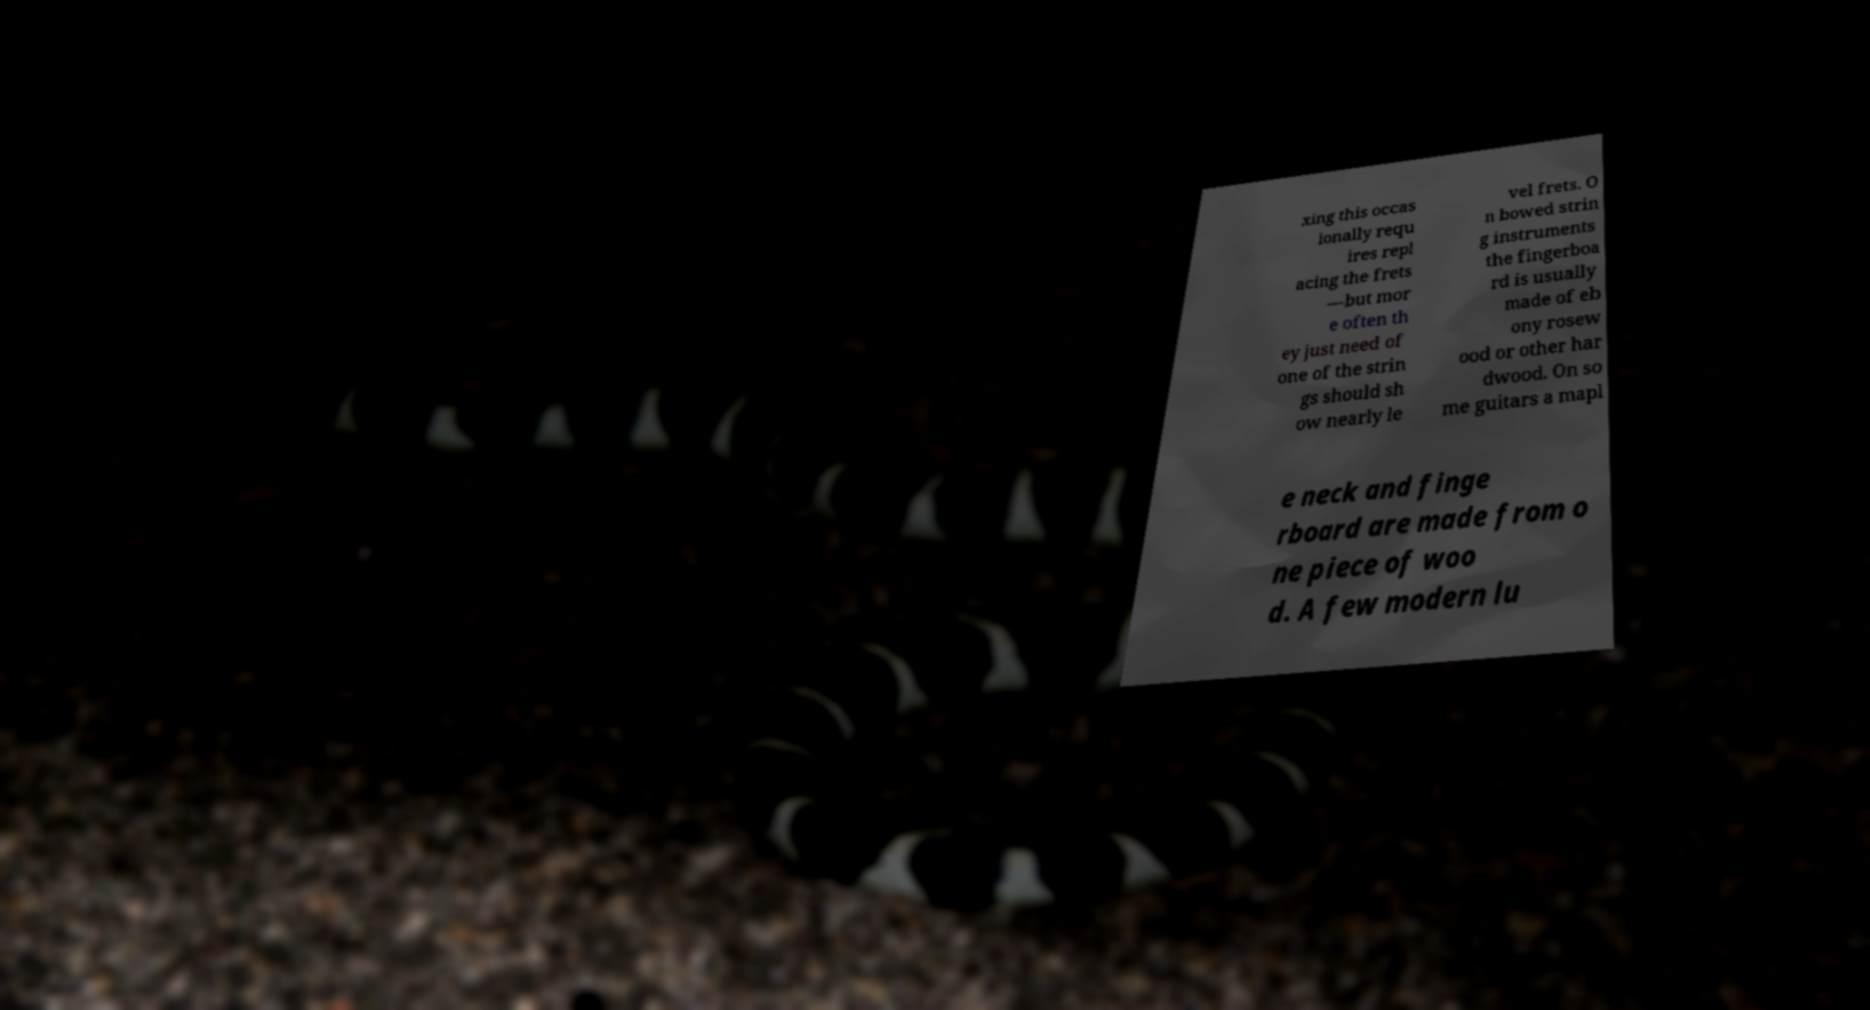I need the written content from this picture converted into text. Can you do that? xing this occas ionally requ ires repl acing the frets —but mor e often th ey just need of one of the strin gs should sh ow nearly le vel frets. O n bowed strin g instruments the fingerboa rd is usually made of eb ony rosew ood or other har dwood. On so me guitars a mapl e neck and finge rboard are made from o ne piece of woo d. A few modern lu 